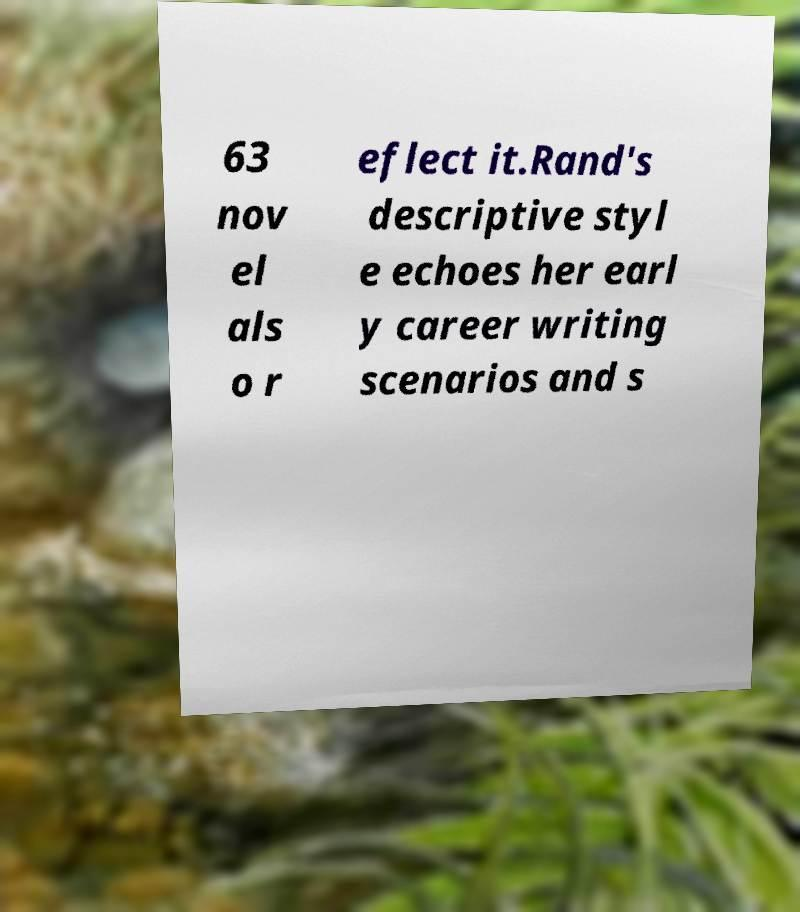Can you accurately transcribe the text from the provided image for me? 63 nov el als o r eflect it.Rand's descriptive styl e echoes her earl y career writing scenarios and s 